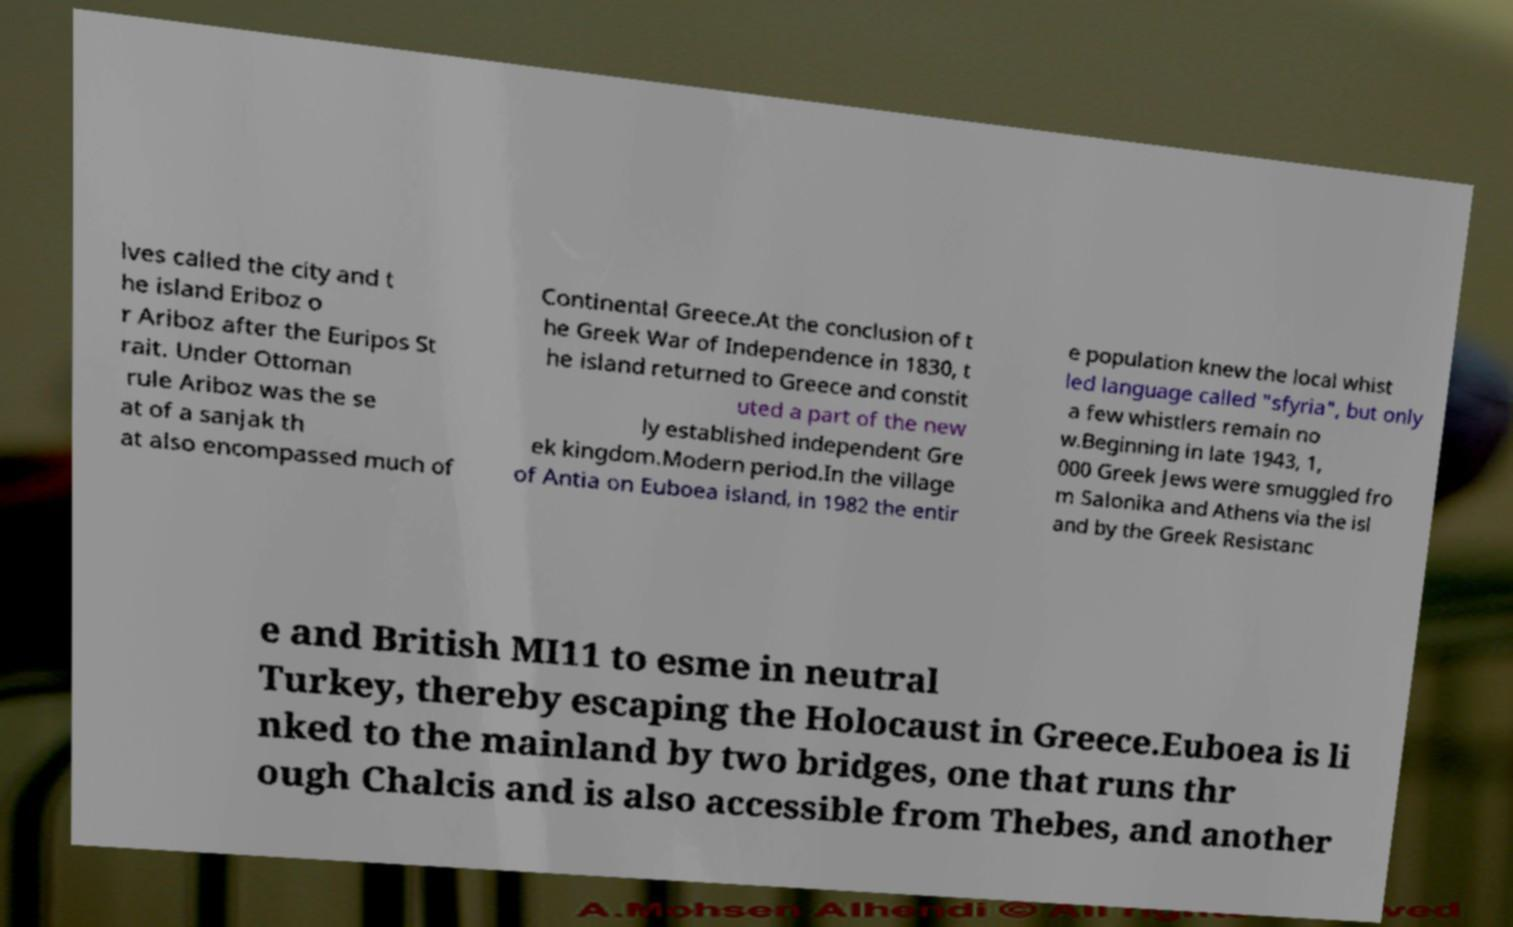Could you extract and type out the text from this image? lves called the city and t he island Eriboz o r Ariboz after the Euripos St rait. Under Ottoman rule Ariboz was the se at of a sanjak th at also encompassed much of Continental Greece.At the conclusion of t he Greek War of Independence in 1830, t he island returned to Greece and constit uted a part of the new ly established independent Gre ek kingdom.Modern period.In the village of Antia on Euboea island, in 1982 the entir e population knew the local whist led language called "sfyria", but only a few whistlers remain no w.Beginning in late 1943, 1, 000 Greek Jews were smuggled fro m Salonika and Athens via the isl and by the Greek Resistanc e and British MI11 to esme in neutral Turkey, thereby escaping the Holocaust in Greece.Euboea is li nked to the mainland by two bridges, one that runs thr ough Chalcis and is also accessible from Thebes, and another 